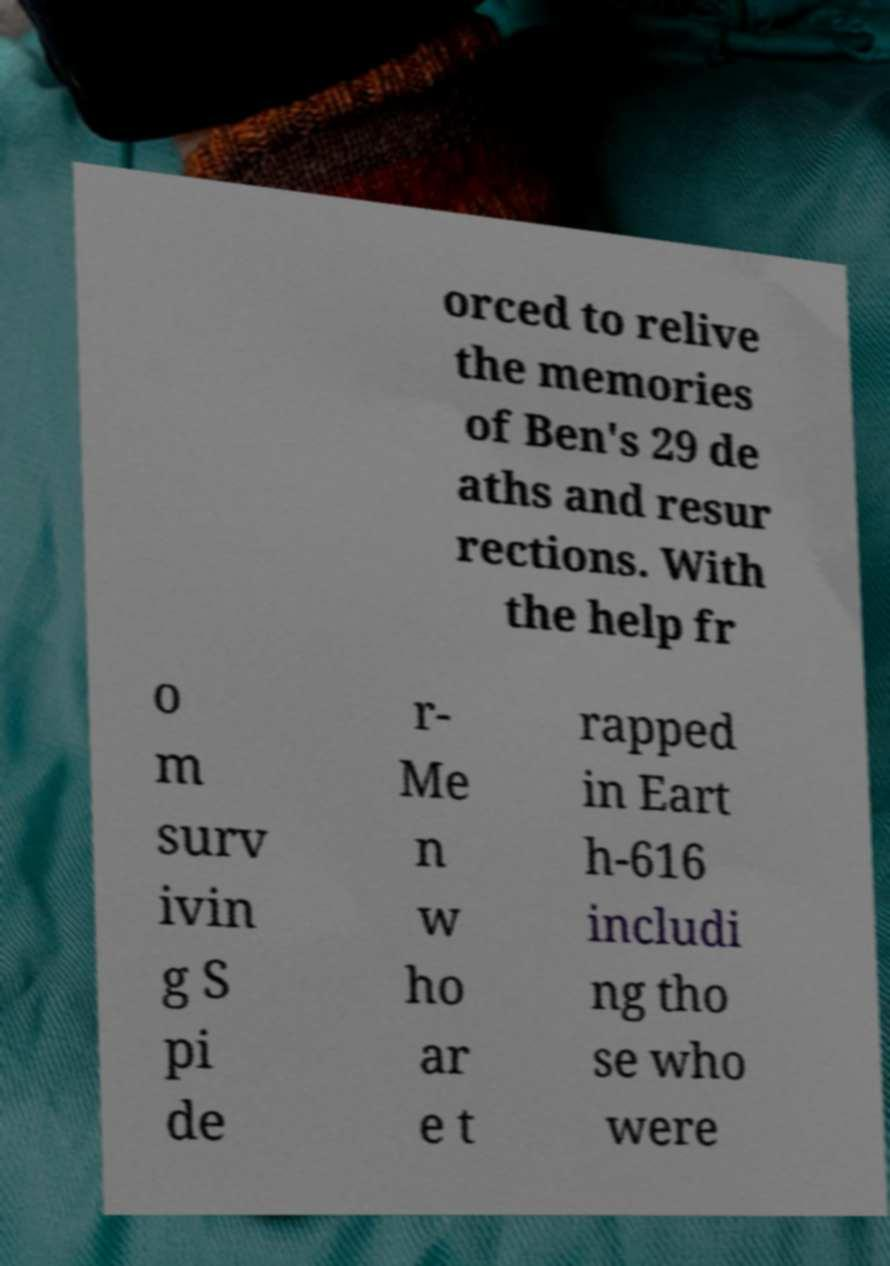Can you accurately transcribe the text from the provided image for me? orced to relive the memories of Ben's 29 de aths and resur rections. With the help fr o m surv ivin g S pi de r- Me n w ho ar e t rapped in Eart h-616 includi ng tho se who were 